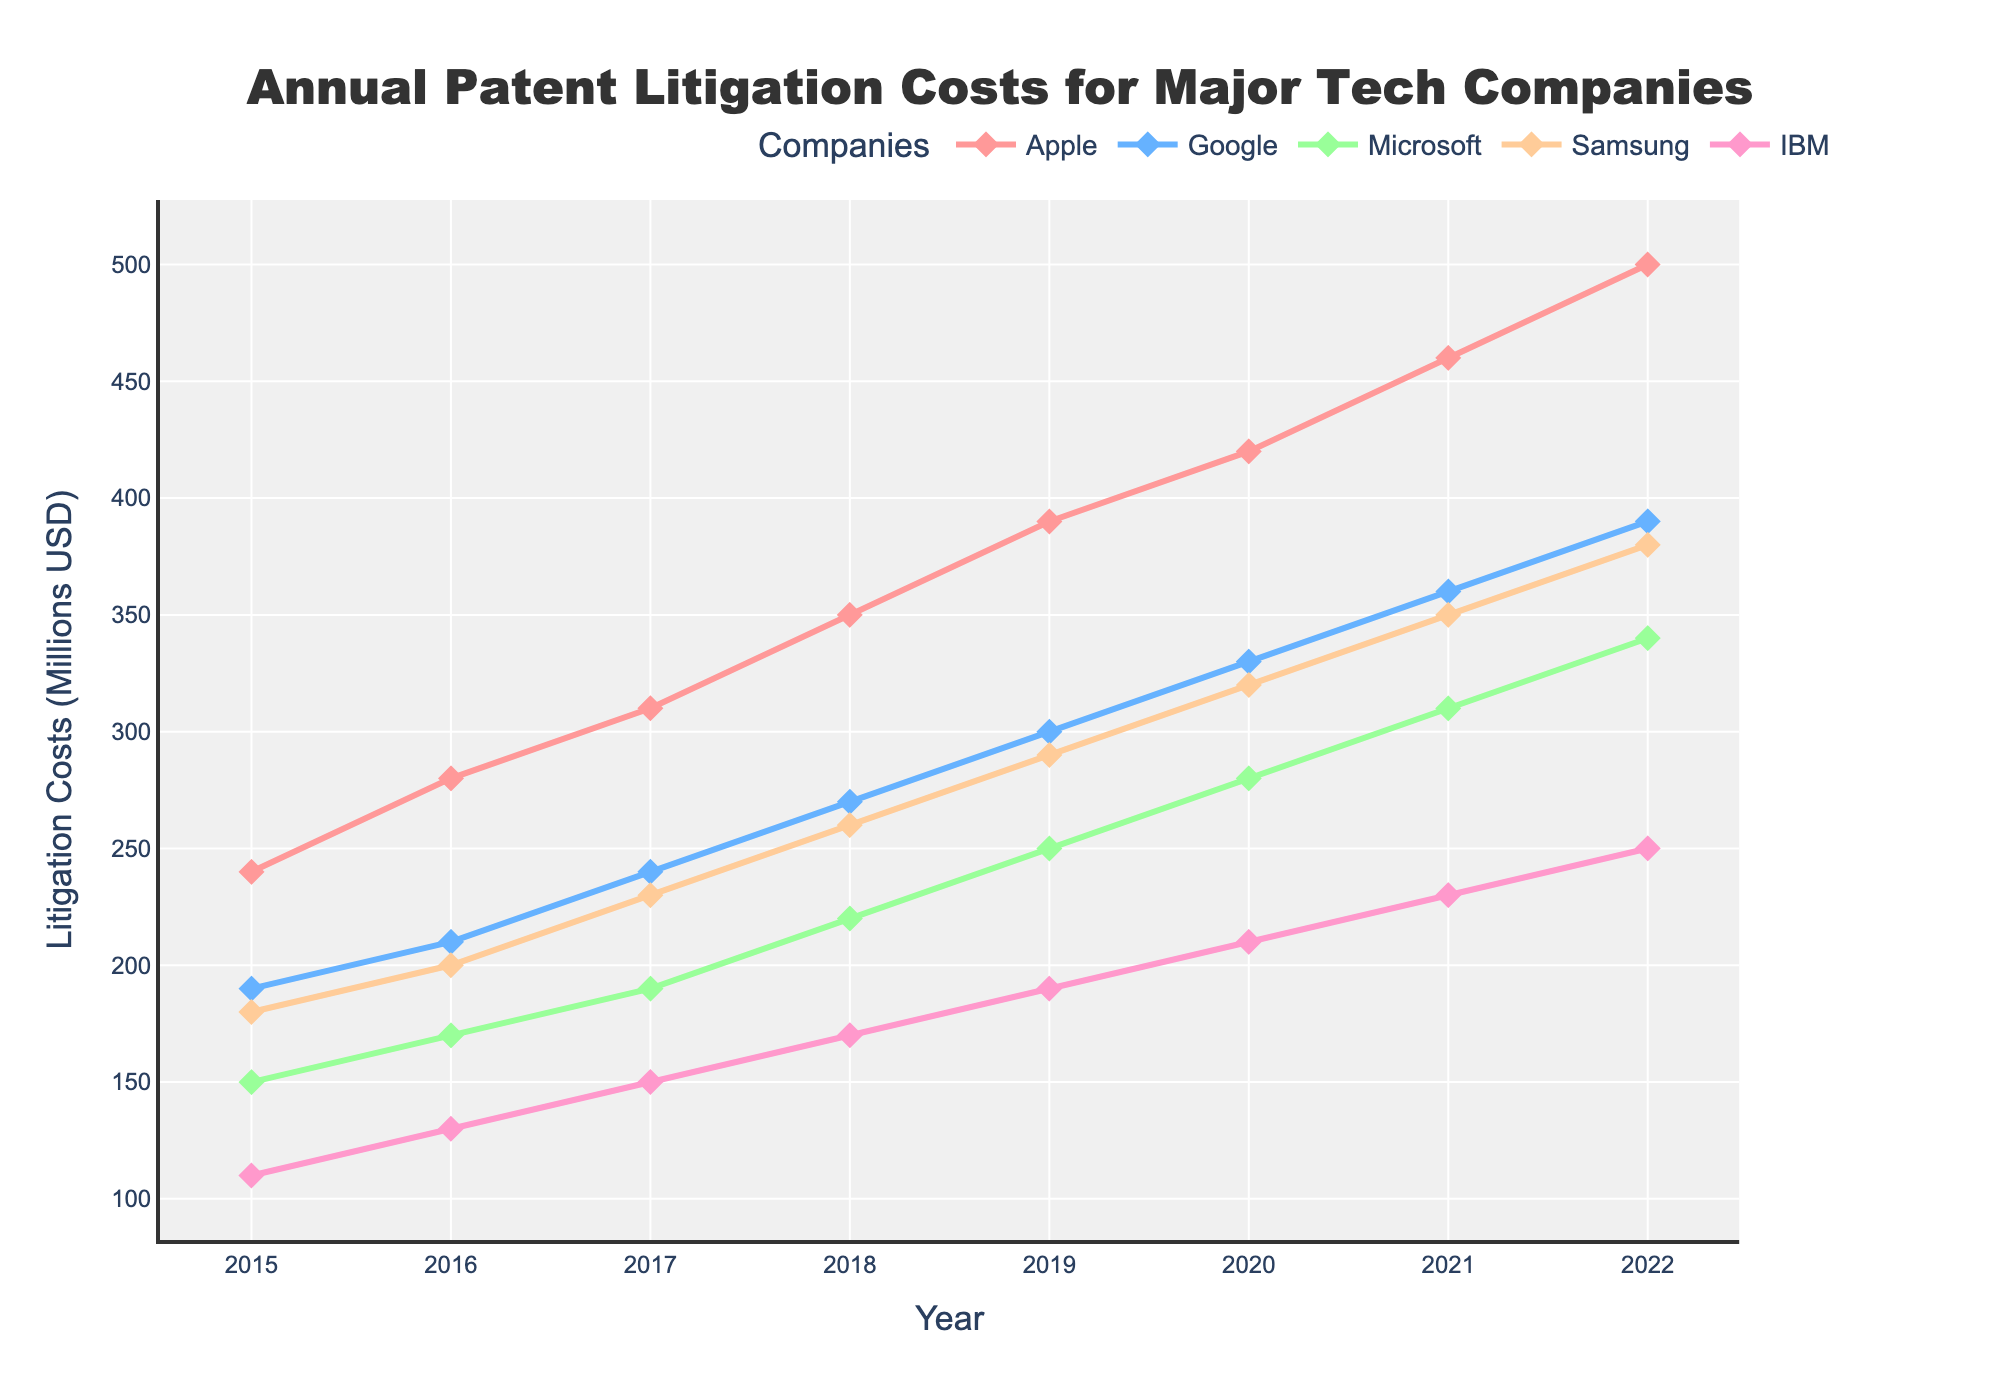What is the general trend of patent litigation costs for Apple from 2015 to 2022? The trend for Apple’s patent litigation costs shows a consistent increase from 2015 to 2022. In 2015, the cost was $240 million, and it increased steadily each year, reaching $500 million in 2022.
Answer: Increasing Which company had the highest patent litigation costs in 2020? By examining the 2020 data points, Apple had the highest costs at $420 million, while other companies had lower values (Google: $330M, Microsoft: $280M, Samsung: $320M, IBM: $210M).
Answer: Apple By how much did Google’s patent litigation costs increase from 2015 to 2022? Google’s costs in 2015 were $190 million and increased to $390 million in 2022. The difference is $390M - $190M = $200M.
Answer: $200 million Which company had the lowest costs in 2019 and what was the value? Review the 2019 data points. IBM had the lowest litigation costs at $190 million.
Answer: IBM; $190 million In which year did Microsoft surpass 200 million in annual patent litigation costs? Microsoft's costs were $150M in 2015, $170M in 2016, $190M in 2017, $220M in 2018, $250M in 2019, $280M in 2020, $310M in 2021, and $340M in 2022. The first year they surpassed $200M was 2018 when they reached $220M.
Answer: 2018 Compare the rate of increase per year for Samsung and IBM from 2015 to 2022. Calculate each year’s increase for Samsung and IBM individually (e.g., Samsung: 2015 $180M - 2016 $200M = $20M increase, etc.). Summarize the increase rate by dividing the total increase by the number of years (2022-2015=7). Samsung total increase is $380M-$180M=$200M; IBM total increase is $250M-$110M=$140M. Therefore, Samsung’s rate is $200M/7 ≈ $28.57M, and IBM’s rate is $140M/7 ≈ $20M per year.
Answer: Samsung: $28.57M per year; IBM: $20M per year Out of all companies, which company had the greatest increase in litigation costs between any two consecutive years? Specify the years. Comparing pairs of consecutive years for each company: Apple from 2021 to 2022 (increase of $500M - $460M = $40M), Google from 2021 to 2022 (increase of $390M - $360M = $30M), Microsoft (2021 to 2022, increase of $340M - $310M = $30M), Samsung (2021 to 2022, increase of $380M - $350M = $30M), IBM (2021 to 2022, increase of $250M - $230M = $20M). The greatest increase is from Apple between 2021 and 2022 with a $40M increase.
Answer: Apple, 2021-2022 What is the average annual patent litigation cost for IBM over the period 2015-2022? IBM’s costs were: 2015: $110M, 2016: $130M, 2017: $150M, 2018: $170M, 2019: $190M, 2020: $210M, 2021: $230M, 2022: $250M. Sum them up, 110 + 130 + 150 + 170 + 190 + 210 + 230 + 250 = 1440; Average = 1440/8 = 180M.
Answer: $180 million 